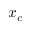Convert formula to latex. <formula><loc_0><loc_0><loc_500><loc_500>x _ { c }</formula> 